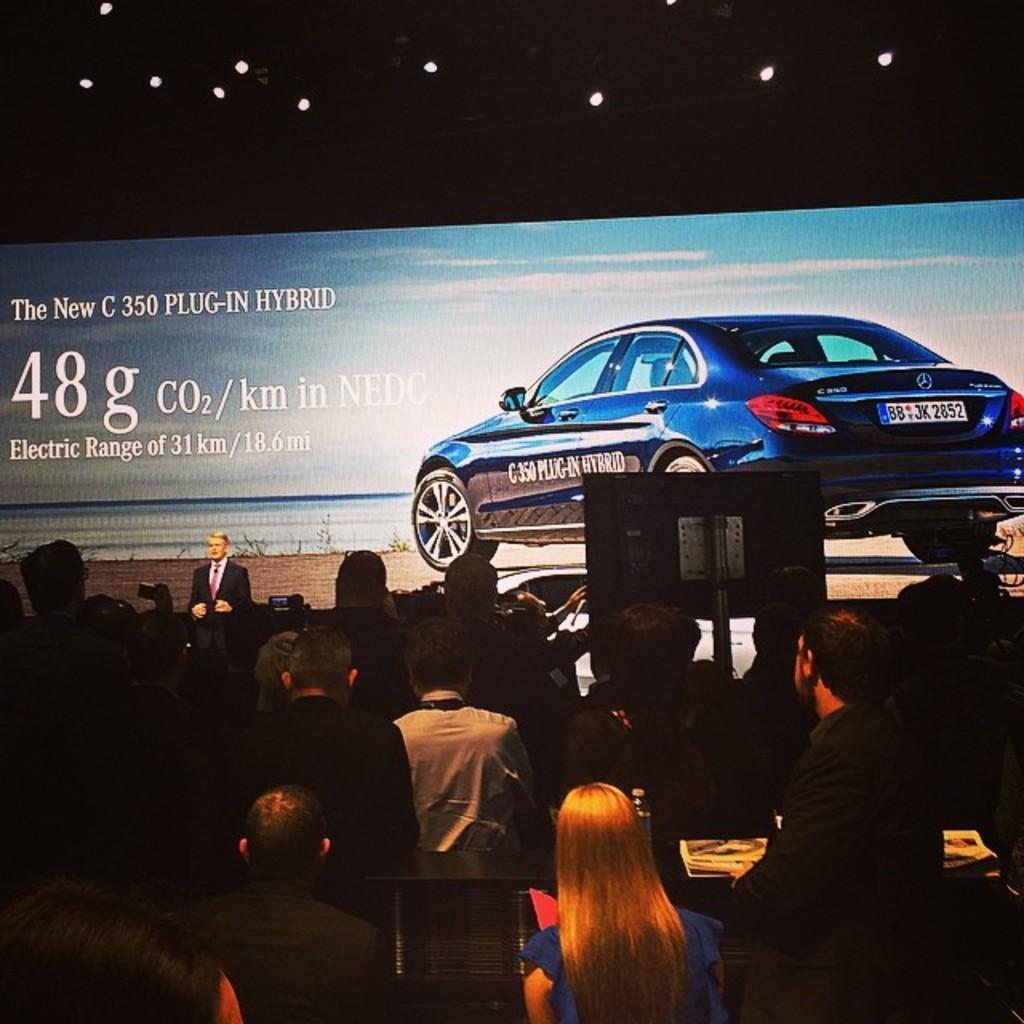How would you summarize this image in a sentence or two? In this image we can see a few people and there is a person standing on the stage, there are some books on the table, in the background, we can see a board with some text and also we can see a vehicle. 